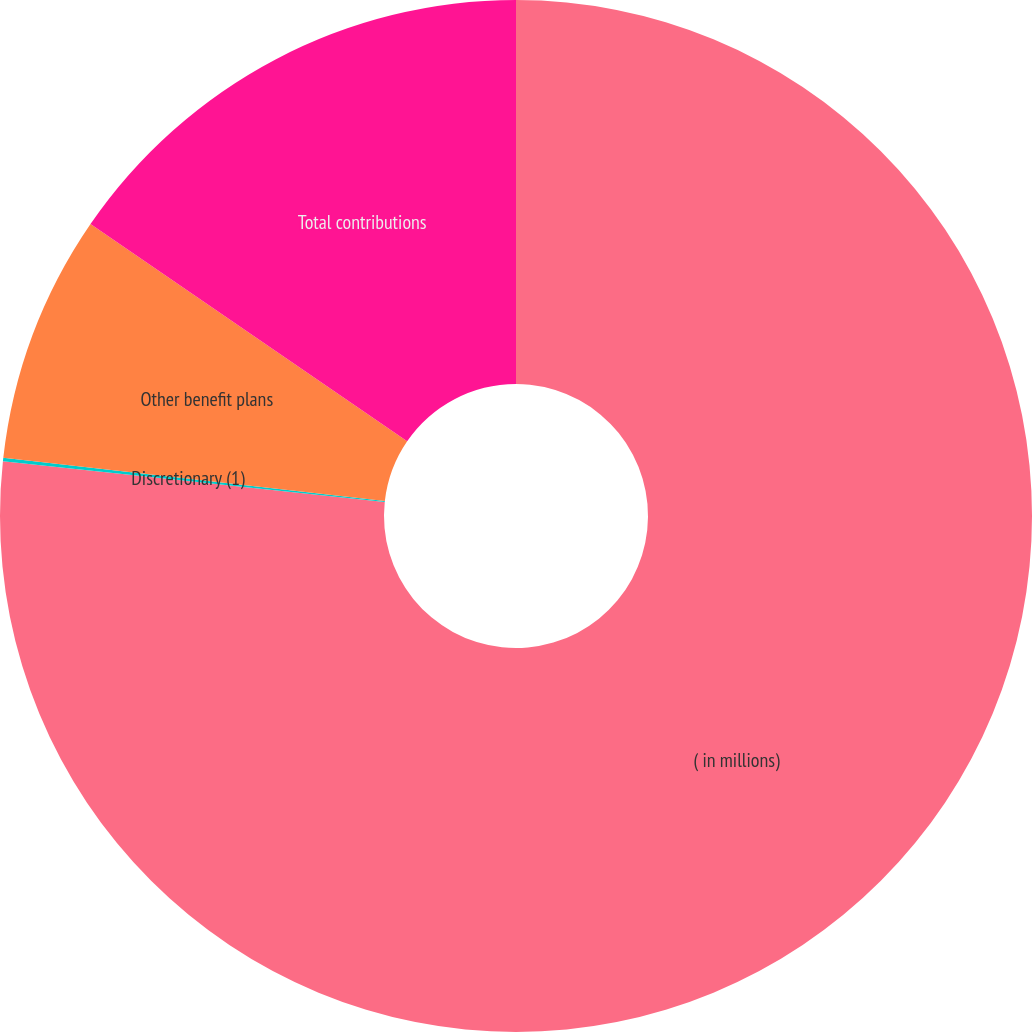Convert chart. <chart><loc_0><loc_0><loc_500><loc_500><pie_chart><fcel>( in millions)<fcel>Discretionary (1)<fcel>Other benefit plans<fcel>Total contributions<nl><fcel>76.69%<fcel>0.11%<fcel>7.77%<fcel>15.43%<nl></chart> 